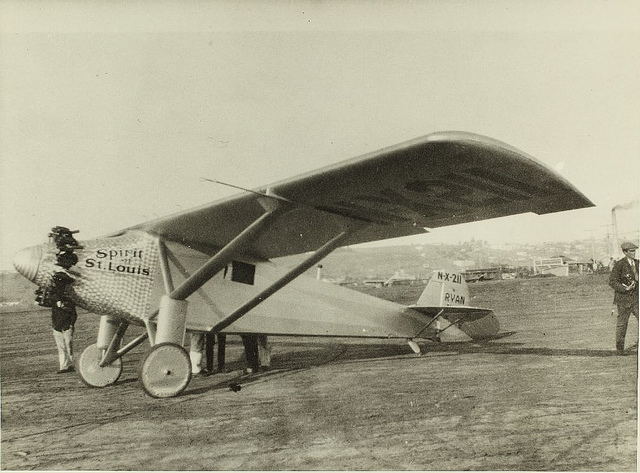<image>What number is on the plane? I don't know what number is on the plane. It could be '211', '20', 'ny 211', 'nx 211', '2', or 'mx211'. What number is on the plane? It is unanswerable what number is on the plane. 